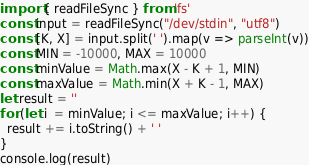Convert code to text. <code><loc_0><loc_0><loc_500><loc_500><_TypeScript_>import { readFileSync } from 'fs'
const input = readFileSync("/dev/stdin", "utf8")
const [K, X] = input.split(' ').map(v => parseInt(v))
const MIN = -10000, MAX = 10000
const minValue = Math.max(X - K + 1, MIN)
const maxValue = Math.min(X + K - 1, MAX)
let result = ''
for (let i  = minValue; i <= maxValue; i++) {
  result += i.toString() + ' '
}
console.log(result)</code> 